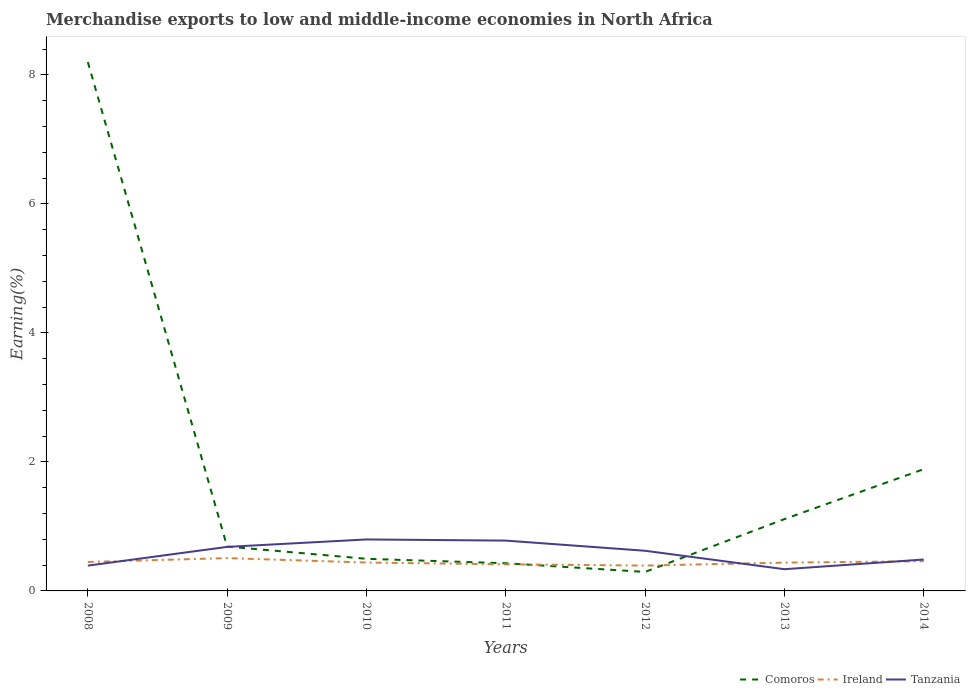How many different coloured lines are there?
Your response must be concise. 3. Is the number of lines equal to the number of legend labels?
Provide a short and direct response. Yes. Across all years, what is the maximum percentage of amount earned from merchandise exports in Tanzania?
Make the answer very short. 0.34. In which year was the percentage of amount earned from merchandise exports in Tanzania maximum?
Make the answer very short. 2013. What is the total percentage of amount earned from merchandise exports in Comoros in the graph?
Make the answer very short. -0.62. What is the difference between the highest and the second highest percentage of amount earned from merchandise exports in Ireland?
Offer a terse response. 0.12. Is the percentage of amount earned from merchandise exports in Ireland strictly greater than the percentage of amount earned from merchandise exports in Comoros over the years?
Your answer should be very brief. No. Does the graph contain any zero values?
Provide a short and direct response. No. Where does the legend appear in the graph?
Your response must be concise. Bottom right. How are the legend labels stacked?
Offer a very short reply. Horizontal. What is the title of the graph?
Ensure brevity in your answer.  Merchandise exports to low and middle-income economies in North Africa. What is the label or title of the X-axis?
Provide a short and direct response. Years. What is the label or title of the Y-axis?
Offer a very short reply. Earning(%). What is the Earning(%) of Comoros in 2008?
Provide a succinct answer. 8.2. What is the Earning(%) of Ireland in 2008?
Give a very brief answer. 0.45. What is the Earning(%) in Tanzania in 2008?
Offer a very short reply. 0.39. What is the Earning(%) of Comoros in 2009?
Provide a short and direct response. 0.69. What is the Earning(%) in Ireland in 2009?
Keep it short and to the point. 0.51. What is the Earning(%) in Tanzania in 2009?
Keep it short and to the point. 0.68. What is the Earning(%) in Comoros in 2010?
Provide a succinct answer. 0.5. What is the Earning(%) of Ireland in 2010?
Offer a terse response. 0.44. What is the Earning(%) in Tanzania in 2010?
Your answer should be very brief. 0.8. What is the Earning(%) of Comoros in 2011?
Your answer should be compact. 0.43. What is the Earning(%) in Ireland in 2011?
Your answer should be very brief. 0.41. What is the Earning(%) in Tanzania in 2011?
Keep it short and to the point. 0.78. What is the Earning(%) in Comoros in 2012?
Provide a short and direct response. 0.29. What is the Earning(%) of Ireland in 2012?
Provide a succinct answer. 0.39. What is the Earning(%) in Tanzania in 2012?
Provide a succinct answer. 0.62. What is the Earning(%) of Comoros in 2013?
Your answer should be compact. 1.11. What is the Earning(%) in Ireland in 2013?
Give a very brief answer. 0.44. What is the Earning(%) in Tanzania in 2013?
Make the answer very short. 0.34. What is the Earning(%) of Comoros in 2014?
Your answer should be compact. 1.89. What is the Earning(%) of Ireland in 2014?
Offer a very short reply. 0.46. What is the Earning(%) of Tanzania in 2014?
Make the answer very short. 0.49. Across all years, what is the maximum Earning(%) in Comoros?
Ensure brevity in your answer.  8.2. Across all years, what is the maximum Earning(%) of Ireland?
Your answer should be compact. 0.51. Across all years, what is the maximum Earning(%) of Tanzania?
Keep it short and to the point. 0.8. Across all years, what is the minimum Earning(%) of Comoros?
Ensure brevity in your answer.  0.29. Across all years, what is the minimum Earning(%) in Ireland?
Your answer should be compact. 0.39. Across all years, what is the minimum Earning(%) of Tanzania?
Make the answer very short. 0.34. What is the total Earning(%) of Comoros in the graph?
Your response must be concise. 13.11. What is the total Earning(%) in Ireland in the graph?
Make the answer very short. 3.1. What is the total Earning(%) in Tanzania in the graph?
Make the answer very short. 4.1. What is the difference between the Earning(%) of Comoros in 2008 and that in 2009?
Provide a short and direct response. 7.51. What is the difference between the Earning(%) of Ireland in 2008 and that in 2009?
Give a very brief answer. -0.06. What is the difference between the Earning(%) of Tanzania in 2008 and that in 2009?
Offer a terse response. -0.29. What is the difference between the Earning(%) of Comoros in 2008 and that in 2010?
Your answer should be compact. 7.7. What is the difference between the Earning(%) of Ireland in 2008 and that in 2010?
Provide a short and direct response. 0.01. What is the difference between the Earning(%) in Tanzania in 2008 and that in 2010?
Offer a terse response. -0.41. What is the difference between the Earning(%) of Comoros in 2008 and that in 2011?
Your response must be concise. 7.77. What is the difference between the Earning(%) in Ireland in 2008 and that in 2011?
Provide a succinct answer. 0.04. What is the difference between the Earning(%) of Tanzania in 2008 and that in 2011?
Offer a very short reply. -0.39. What is the difference between the Earning(%) of Comoros in 2008 and that in 2012?
Keep it short and to the point. 7.9. What is the difference between the Earning(%) in Ireland in 2008 and that in 2012?
Offer a terse response. 0.06. What is the difference between the Earning(%) in Tanzania in 2008 and that in 2012?
Keep it short and to the point. -0.23. What is the difference between the Earning(%) of Comoros in 2008 and that in 2013?
Your answer should be compact. 7.09. What is the difference between the Earning(%) in Ireland in 2008 and that in 2013?
Your answer should be very brief. 0.01. What is the difference between the Earning(%) of Tanzania in 2008 and that in 2013?
Offer a very short reply. 0.06. What is the difference between the Earning(%) of Comoros in 2008 and that in 2014?
Offer a terse response. 6.31. What is the difference between the Earning(%) of Ireland in 2008 and that in 2014?
Keep it short and to the point. -0.01. What is the difference between the Earning(%) in Tanzania in 2008 and that in 2014?
Offer a terse response. -0.09. What is the difference between the Earning(%) in Comoros in 2009 and that in 2010?
Keep it short and to the point. 0.19. What is the difference between the Earning(%) of Ireland in 2009 and that in 2010?
Make the answer very short. 0.07. What is the difference between the Earning(%) in Tanzania in 2009 and that in 2010?
Your response must be concise. -0.12. What is the difference between the Earning(%) in Comoros in 2009 and that in 2011?
Give a very brief answer. 0.26. What is the difference between the Earning(%) of Ireland in 2009 and that in 2011?
Ensure brevity in your answer.  0.1. What is the difference between the Earning(%) of Tanzania in 2009 and that in 2011?
Your answer should be very brief. -0.1. What is the difference between the Earning(%) of Comoros in 2009 and that in 2012?
Keep it short and to the point. 0.39. What is the difference between the Earning(%) in Ireland in 2009 and that in 2012?
Offer a terse response. 0.12. What is the difference between the Earning(%) of Tanzania in 2009 and that in 2012?
Your answer should be very brief. 0.06. What is the difference between the Earning(%) in Comoros in 2009 and that in 2013?
Your response must be concise. -0.43. What is the difference between the Earning(%) in Ireland in 2009 and that in 2013?
Ensure brevity in your answer.  0.07. What is the difference between the Earning(%) of Tanzania in 2009 and that in 2013?
Your answer should be compact. 0.35. What is the difference between the Earning(%) in Comoros in 2009 and that in 2014?
Provide a short and direct response. -1.2. What is the difference between the Earning(%) of Ireland in 2009 and that in 2014?
Offer a very short reply. 0.05. What is the difference between the Earning(%) in Tanzania in 2009 and that in 2014?
Your answer should be compact. 0.2. What is the difference between the Earning(%) of Comoros in 2010 and that in 2011?
Keep it short and to the point. 0.07. What is the difference between the Earning(%) in Ireland in 2010 and that in 2011?
Your answer should be very brief. 0.03. What is the difference between the Earning(%) of Tanzania in 2010 and that in 2011?
Provide a succinct answer. 0.02. What is the difference between the Earning(%) in Comoros in 2010 and that in 2012?
Your response must be concise. 0.2. What is the difference between the Earning(%) in Ireland in 2010 and that in 2012?
Offer a very short reply. 0.05. What is the difference between the Earning(%) in Tanzania in 2010 and that in 2012?
Offer a very short reply. 0.18. What is the difference between the Earning(%) in Comoros in 2010 and that in 2013?
Make the answer very short. -0.62. What is the difference between the Earning(%) in Ireland in 2010 and that in 2013?
Offer a very short reply. 0. What is the difference between the Earning(%) of Tanzania in 2010 and that in 2013?
Your answer should be compact. 0.46. What is the difference between the Earning(%) of Comoros in 2010 and that in 2014?
Your answer should be compact. -1.39. What is the difference between the Earning(%) in Ireland in 2010 and that in 2014?
Provide a succinct answer. -0.02. What is the difference between the Earning(%) of Tanzania in 2010 and that in 2014?
Provide a succinct answer. 0.31. What is the difference between the Earning(%) in Comoros in 2011 and that in 2012?
Offer a terse response. 0.13. What is the difference between the Earning(%) of Ireland in 2011 and that in 2012?
Offer a very short reply. 0.02. What is the difference between the Earning(%) in Tanzania in 2011 and that in 2012?
Keep it short and to the point. 0.16. What is the difference between the Earning(%) in Comoros in 2011 and that in 2013?
Provide a short and direct response. -0.68. What is the difference between the Earning(%) of Ireland in 2011 and that in 2013?
Keep it short and to the point. -0.03. What is the difference between the Earning(%) in Tanzania in 2011 and that in 2013?
Make the answer very short. 0.44. What is the difference between the Earning(%) in Comoros in 2011 and that in 2014?
Give a very brief answer. -1.46. What is the difference between the Earning(%) in Ireland in 2011 and that in 2014?
Give a very brief answer. -0.05. What is the difference between the Earning(%) of Tanzania in 2011 and that in 2014?
Provide a short and direct response. 0.29. What is the difference between the Earning(%) of Comoros in 2012 and that in 2013?
Offer a very short reply. -0.82. What is the difference between the Earning(%) in Ireland in 2012 and that in 2013?
Make the answer very short. -0.05. What is the difference between the Earning(%) in Tanzania in 2012 and that in 2013?
Offer a very short reply. 0.29. What is the difference between the Earning(%) of Comoros in 2012 and that in 2014?
Give a very brief answer. -1.59. What is the difference between the Earning(%) of Ireland in 2012 and that in 2014?
Keep it short and to the point. -0.07. What is the difference between the Earning(%) of Tanzania in 2012 and that in 2014?
Your answer should be very brief. 0.14. What is the difference between the Earning(%) of Comoros in 2013 and that in 2014?
Keep it short and to the point. -0.77. What is the difference between the Earning(%) of Ireland in 2013 and that in 2014?
Give a very brief answer. -0.02. What is the difference between the Earning(%) of Tanzania in 2013 and that in 2014?
Keep it short and to the point. -0.15. What is the difference between the Earning(%) in Comoros in 2008 and the Earning(%) in Ireland in 2009?
Provide a short and direct response. 7.69. What is the difference between the Earning(%) of Comoros in 2008 and the Earning(%) of Tanzania in 2009?
Your response must be concise. 7.52. What is the difference between the Earning(%) in Ireland in 2008 and the Earning(%) in Tanzania in 2009?
Give a very brief answer. -0.23. What is the difference between the Earning(%) of Comoros in 2008 and the Earning(%) of Ireland in 2010?
Your answer should be compact. 7.76. What is the difference between the Earning(%) of Comoros in 2008 and the Earning(%) of Tanzania in 2010?
Give a very brief answer. 7.4. What is the difference between the Earning(%) of Ireland in 2008 and the Earning(%) of Tanzania in 2010?
Make the answer very short. -0.35. What is the difference between the Earning(%) of Comoros in 2008 and the Earning(%) of Ireland in 2011?
Offer a terse response. 7.79. What is the difference between the Earning(%) in Comoros in 2008 and the Earning(%) in Tanzania in 2011?
Your answer should be very brief. 7.42. What is the difference between the Earning(%) in Ireland in 2008 and the Earning(%) in Tanzania in 2011?
Your answer should be compact. -0.33. What is the difference between the Earning(%) of Comoros in 2008 and the Earning(%) of Ireland in 2012?
Keep it short and to the point. 7.81. What is the difference between the Earning(%) in Comoros in 2008 and the Earning(%) in Tanzania in 2012?
Keep it short and to the point. 7.58. What is the difference between the Earning(%) in Ireland in 2008 and the Earning(%) in Tanzania in 2012?
Make the answer very short. -0.17. What is the difference between the Earning(%) of Comoros in 2008 and the Earning(%) of Ireland in 2013?
Provide a short and direct response. 7.76. What is the difference between the Earning(%) of Comoros in 2008 and the Earning(%) of Tanzania in 2013?
Your answer should be very brief. 7.86. What is the difference between the Earning(%) of Ireland in 2008 and the Earning(%) of Tanzania in 2013?
Your response must be concise. 0.11. What is the difference between the Earning(%) of Comoros in 2008 and the Earning(%) of Ireland in 2014?
Your response must be concise. 7.74. What is the difference between the Earning(%) in Comoros in 2008 and the Earning(%) in Tanzania in 2014?
Give a very brief answer. 7.71. What is the difference between the Earning(%) in Ireland in 2008 and the Earning(%) in Tanzania in 2014?
Keep it short and to the point. -0.04. What is the difference between the Earning(%) of Comoros in 2009 and the Earning(%) of Ireland in 2010?
Give a very brief answer. 0.25. What is the difference between the Earning(%) in Comoros in 2009 and the Earning(%) in Tanzania in 2010?
Provide a short and direct response. -0.11. What is the difference between the Earning(%) in Ireland in 2009 and the Earning(%) in Tanzania in 2010?
Provide a short and direct response. -0.29. What is the difference between the Earning(%) in Comoros in 2009 and the Earning(%) in Ireland in 2011?
Provide a short and direct response. 0.28. What is the difference between the Earning(%) in Comoros in 2009 and the Earning(%) in Tanzania in 2011?
Give a very brief answer. -0.09. What is the difference between the Earning(%) of Ireland in 2009 and the Earning(%) of Tanzania in 2011?
Your response must be concise. -0.27. What is the difference between the Earning(%) in Comoros in 2009 and the Earning(%) in Ireland in 2012?
Your response must be concise. 0.29. What is the difference between the Earning(%) of Comoros in 2009 and the Earning(%) of Tanzania in 2012?
Provide a short and direct response. 0.07. What is the difference between the Earning(%) in Ireland in 2009 and the Earning(%) in Tanzania in 2012?
Offer a terse response. -0.11. What is the difference between the Earning(%) in Comoros in 2009 and the Earning(%) in Ireland in 2013?
Your response must be concise. 0.25. What is the difference between the Earning(%) in Comoros in 2009 and the Earning(%) in Tanzania in 2013?
Offer a terse response. 0.35. What is the difference between the Earning(%) in Ireland in 2009 and the Earning(%) in Tanzania in 2013?
Your response must be concise. 0.17. What is the difference between the Earning(%) in Comoros in 2009 and the Earning(%) in Ireland in 2014?
Keep it short and to the point. 0.23. What is the difference between the Earning(%) in Comoros in 2009 and the Earning(%) in Tanzania in 2014?
Ensure brevity in your answer.  0.2. What is the difference between the Earning(%) in Ireland in 2009 and the Earning(%) in Tanzania in 2014?
Provide a succinct answer. 0.02. What is the difference between the Earning(%) in Comoros in 2010 and the Earning(%) in Ireland in 2011?
Provide a succinct answer. 0.09. What is the difference between the Earning(%) in Comoros in 2010 and the Earning(%) in Tanzania in 2011?
Ensure brevity in your answer.  -0.28. What is the difference between the Earning(%) in Ireland in 2010 and the Earning(%) in Tanzania in 2011?
Your answer should be compact. -0.34. What is the difference between the Earning(%) of Comoros in 2010 and the Earning(%) of Ireland in 2012?
Your answer should be compact. 0.1. What is the difference between the Earning(%) of Comoros in 2010 and the Earning(%) of Tanzania in 2012?
Your response must be concise. -0.12. What is the difference between the Earning(%) of Ireland in 2010 and the Earning(%) of Tanzania in 2012?
Offer a very short reply. -0.18. What is the difference between the Earning(%) in Comoros in 2010 and the Earning(%) in Ireland in 2013?
Your answer should be very brief. 0.06. What is the difference between the Earning(%) of Comoros in 2010 and the Earning(%) of Tanzania in 2013?
Give a very brief answer. 0.16. What is the difference between the Earning(%) of Ireland in 2010 and the Earning(%) of Tanzania in 2013?
Keep it short and to the point. 0.1. What is the difference between the Earning(%) of Comoros in 2010 and the Earning(%) of Ireland in 2014?
Your answer should be very brief. 0.04. What is the difference between the Earning(%) in Comoros in 2010 and the Earning(%) in Tanzania in 2014?
Keep it short and to the point. 0.01. What is the difference between the Earning(%) in Ireland in 2010 and the Earning(%) in Tanzania in 2014?
Offer a very short reply. -0.05. What is the difference between the Earning(%) in Comoros in 2011 and the Earning(%) in Ireland in 2012?
Your answer should be compact. 0.04. What is the difference between the Earning(%) in Comoros in 2011 and the Earning(%) in Tanzania in 2012?
Offer a terse response. -0.19. What is the difference between the Earning(%) in Ireland in 2011 and the Earning(%) in Tanzania in 2012?
Offer a very short reply. -0.21. What is the difference between the Earning(%) in Comoros in 2011 and the Earning(%) in Ireland in 2013?
Make the answer very short. -0.01. What is the difference between the Earning(%) of Comoros in 2011 and the Earning(%) of Tanzania in 2013?
Offer a terse response. 0.09. What is the difference between the Earning(%) of Ireland in 2011 and the Earning(%) of Tanzania in 2013?
Your answer should be compact. 0.08. What is the difference between the Earning(%) in Comoros in 2011 and the Earning(%) in Ireland in 2014?
Provide a succinct answer. -0.03. What is the difference between the Earning(%) in Comoros in 2011 and the Earning(%) in Tanzania in 2014?
Your answer should be very brief. -0.06. What is the difference between the Earning(%) in Ireland in 2011 and the Earning(%) in Tanzania in 2014?
Your answer should be very brief. -0.07. What is the difference between the Earning(%) of Comoros in 2012 and the Earning(%) of Ireland in 2013?
Provide a short and direct response. -0.14. What is the difference between the Earning(%) of Comoros in 2012 and the Earning(%) of Tanzania in 2013?
Your answer should be very brief. -0.04. What is the difference between the Earning(%) of Ireland in 2012 and the Earning(%) of Tanzania in 2013?
Keep it short and to the point. 0.06. What is the difference between the Earning(%) in Comoros in 2012 and the Earning(%) in Ireland in 2014?
Offer a terse response. -0.17. What is the difference between the Earning(%) in Comoros in 2012 and the Earning(%) in Tanzania in 2014?
Your answer should be compact. -0.19. What is the difference between the Earning(%) in Ireland in 2012 and the Earning(%) in Tanzania in 2014?
Make the answer very short. -0.09. What is the difference between the Earning(%) in Comoros in 2013 and the Earning(%) in Ireland in 2014?
Provide a succinct answer. 0.65. What is the difference between the Earning(%) in Comoros in 2013 and the Earning(%) in Tanzania in 2014?
Provide a succinct answer. 0.63. What is the difference between the Earning(%) of Ireland in 2013 and the Earning(%) of Tanzania in 2014?
Provide a succinct answer. -0.05. What is the average Earning(%) in Comoros per year?
Keep it short and to the point. 1.87. What is the average Earning(%) in Ireland per year?
Your answer should be compact. 0.44. What is the average Earning(%) in Tanzania per year?
Your answer should be compact. 0.59. In the year 2008, what is the difference between the Earning(%) of Comoros and Earning(%) of Ireland?
Offer a very short reply. 7.75. In the year 2008, what is the difference between the Earning(%) in Comoros and Earning(%) in Tanzania?
Your answer should be very brief. 7.81. In the year 2008, what is the difference between the Earning(%) in Ireland and Earning(%) in Tanzania?
Your answer should be very brief. 0.06. In the year 2009, what is the difference between the Earning(%) in Comoros and Earning(%) in Ireland?
Make the answer very short. 0.18. In the year 2009, what is the difference between the Earning(%) in Comoros and Earning(%) in Tanzania?
Keep it short and to the point. 0.01. In the year 2009, what is the difference between the Earning(%) in Ireland and Earning(%) in Tanzania?
Provide a short and direct response. -0.17. In the year 2010, what is the difference between the Earning(%) of Comoros and Earning(%) of Ireland?
Provide a succinct answer. 0.06. In the year 2010, what is the difference between the Earning(%) in Comoros and Earning(%) in Tanzania?
Your answer should be compact. -0.3. In the year 2010, what is the difference between the Earning(%) of Ireland and Earning(%) of Tanzania?
Provide a succinct answer. -0.36. In the year 2011, what is the difference between the Earning(%) in Comoros and Earning(%) in Ireland?
Provide a succinct answer. 0.02. In the year 2011, what is the difference between the Earning(%) of Comoros and Earning(%) of Tanzania?
Keep it short and to the point. -0.35. In the year 2011, what is the difference between the Earning(%) in Ireland and Earning(%) in Tanzania?
Offer a terse response. -0.37. In the year 2012, what is the difference between the Earning(%) in Comoros and Earning(%) in Ireland?
Provide a short and direct response. -0.1. In the year 2012, what is the difference between the Earning(%) in Comoros and Earning(%) in Tanzania?
Provide a short and direct response. -0.33. In the year 2012, what is the difference between the Earning(%) of Ireland and Earning(%) of Tanzania?
Give a very brief answer. -0.23. In the year 2013, what is the difference between the Earning(%) in Comoros and Earning(%) in Ireland?
Give a very brief answer. 0.67. In the year 2013, what is the difference between the Earning(%) of Comoros and Earning(%) of Tanzania?
Offer a very short reply. 0.78. In the year 2013, what is the difference between the Earning(%) in Ireland and Earning(%) in Tanzania?
Give a very brief answer. 0.1. In the year 2014, what is the difference between the Earning(%) of Comoros and Earning(%) of Ireland?
Offer a terse response. 1.43. In the year 2014, what is the difference between the Earning(%) of Comoros and Earning(%) of Tanzania?
Your answer should be compact. 1.4. In the year 2014, what is the difference between the Earning(%) in Ireland and Earning(%) in Tanzania?
Make the answer very short. -0.03. What is the ratio of the Earning(%) in Comoros in 2008 to that in 2009?
Your response must be concise. 11.92. What is the ratio of the Earning(%) of Ireland in 2008 to that in 2009?
Give a very brief answer. 0.88. What is the ratio of the Earning(%) of Tanzania in 2008 to that in 2009?
Make the answer very short. 0.57. What is the ratio of the Earning(%) in Comoros in 2008 to that in 2010?
Offer a very short reply. 16.46. What is the ratio of the Earning(%) of Ireland in 2008 to that in 2010?
Provide a succinct answer. 1.02. What is the ratio of the Earning(%) of Tanzania in 2008 to that in 2010?
Ensure brevity in your answer.  0.49. What is the ratio of the Earning(%) of Comoros in 2008 to that in 2011?
Your answer should be compact. 19.11. What is the ratio of the Earning(%) in Ireland in 2008 to that in 2011?
Your answer should be compact. 1.09. What is the ratio of the Earning(%) in Tanzania in 2008 to that in 2011?
Your answer should be compact. 0.5. What is the ratio of the Earning(%) in Comoros in 2008 to that in 2012?
Offer a very short reply. 27.83. What is the ratio of the Earning(%) of Ireland in 2008 to that in 2012?
Offer a very short reply. 1.14. What is the ratio of the Earning(%) of Tanzania in 2008 to that in 2012?
Offer a very short reply. 0.63. What is the ratio of the Earning(%) in Comoros in 2008 to that in 2013?
Give a very brief answer. 7.37. What is the ratio of the Earning(%) of Tanzania in 2008 to that in 2013?
Provide a short and direct response. 1.16. What is the ratio of the Earning(%) of Comoros in 2008 to that in 2014?
Provide a succinct answer. 4.34. What is the ratio of the Earning(%) of Ireland in 2008 to that in 2014?
Your answer should be compact. 0.97. What is the ratio of the Earning(%) of Tanzania in 2008 to that in 2014?
Make the answer very short. 0.81. What is the ratio of the Earning(%) of Comoros in 2009 to that in 2010?
Give a very brief answer. 1.38. What is the ratio of the Earning(%) of Ireland in 2009 to that in 2010?
Ensure brevity in your answer.  1.16. What is the ratio of the Earning(%) of Tanzania in 2009 to that in 2010?
Your answer should be very brief. 0.86. What is the ratio of the Earning(%) in Comoros in 2009 to that in 2011?
Provide a succinct answer. 1.6. What is the ratio of the Earning(%) of Ireland in 2009 to that in 2011?
Ensure brevity in your answer.  1.23. What is the ratio of the Earning(%) in Tanzania in 2009 to that in 2011?
Offer a very short reply. 0.88. What is the ratio of the Earning(%) in Comoros in 2009 to that in 2012?
Ensure brevity in your answer.  2.33. What is the ratio of the Earning(%) in Ireland in 2009 to that in 2012?
Make the answer very short. 1.29. What is the ratio of the Earning(%) of Tanzania in 2009 to that in 2012?
Your response must be concise. 1.1. What is the ratio of the Earning(%) in Comoros in 2009 to that in 2013?
Make the answer very short. 0.62. What is the ratio of the Earning(%) in Ireland in 2009 to that in 2013?
Offer a terse response. 1.16. What is the ratio of the Earning(%) of Tanzania in 2009 to that in 2013?
Offer a very short reply. 2.03. What is the ratio of the Earning(%) in Comoros in 2009 to that in 2014?
Ensure brevity in your answer.  0.36. What is the ratio of the Earning(%) in Ireland in 2009 to that in 2014?
Give a very brief answer. 1.1. What is the ratio of the Earning(%) of Tanzania in 2009 to that in 2014?
Provide a short and direct response. 1.4. What is the ratio of the Earning(%) of Comoros in 2010 to that in 2011?
Ensure brevity in your answer.  1.16. What is the ratio of the Earning(%) of Ireland in 2010 to that in 2011?
Ensure brevity in your answer.  1.07. What is the ratio of the Earning(%) of Tanzania in 2010 to that in 2011?
Provide a short and direct response. 1.02. What is the ratio of the Earning(%) in Comoros in 2010 to that in 2012?
Your answer should be compact. 1.69. What is the ratio of the Earning(%) in Ireland in 2010 to that in 2012?
Offer a very short reply. 1.12. What is the ratio of the Earning(%) of Tanzania in 2010 to that in 2012?
Provide a short and direct response. 1.28. What is the ratio of the Earning(%) of Comoros in 2010 to that in 2013?
Give a very brief answer. 0.45. What is the ratio of the Earning(%) in Ireland in 2010 to that in 2013?
Keep it short and to the point. 1. What is the ratio of the Earning(%) of Tanzania in 2010 to that in 2013?
Make the answer very short. 2.37. What is the ratio of the Earning(%) of Comoros in 2010 to that in 2014?
Your answer should be very brief. 0.26. What is the ratio of the Earning(%) of Ireland in 2010 to that in 2014?
Provide a succinct answer. 0.96. What is the ratio of the Earning(%) of Tanzania in 2010 to that in 2014?
Provide a short and direct response. 1.64. What is the ratio of the Earning(%) of Comoros in 2011 to that in 2012?
Keep it short and to the point. 1.46. What is the ratio of the Earning(%) in Tanzania in 2011 to that in 2012?
Make the answer very short. 1.25. What is the ratio of the Earning(%) in Comoros in 2011 to that in 2013?
Make the answer very short. 0.39. What is the ratio of the Earning(%) of Ireland in 2011 to that in 2013?
Ensure brevity in your answer.  0.94. What is the ratio of the Earning(%) of Tanzania in 2011 to that in 2013?
Offer a terse response. 2.32. What is the ratio of the Earning(%) in Comoros in 2011 to that in 2014?
Make the answer very short. 0.23. What is the ratio of the Earning(%) of Ireland in 2011 to that in 2014?
Your answer should be compact. 0.9. What is the ratio of the Earning(%) in Tanzania in 2011 to that in 2014?
Provide a succinct answer. 1.6. What is the ratio of the Earning(%) of Comoros in 2012 to that in 2013?
Offer a very short reply. 0.26. What is the ratio of the Earning(%) in Ireland in 2012 to that in 2013?
Give a very brief answer. 0.9. What is the ratio of the Earning(%) in Tanzania in 2012 to that in 2013?
Your response must be concise. 1.85. What is the ratio of the Earning(%) in Comoros in 2012 to that in 2014?
Your answer should be very brief. 0.16. What is the ratio of the Earning(%) of Ireland in 2012 to that in 2014?
Your answer should be compact. 0.85. What is the ratio of the Earning(%) of Tanzania in 2012 to that in 2014?
Offer a very short reply. 1.28. What is the ratio of the Earning(%) in Comoros in 2013 to that in 2014?
Your answer should be compact. 0.59. What is the ratio of the Earning(%) of Ireland in 2013 to that in 2014?
Keep it short and to the point. 0.95. What is the ratio of the Earning(%) of Tanzania in 2013 to that in 2014?
Give a very brief answer. 0.69. What is the difference between the highest and the second highest Earning(%) of Comoros?
Keep it short and to the point. 6.31. What is the difference between the highest and the second highest Earning(%) in Ireland?
Offer a terse response. 0.05. What is the difference between the highest and the second highest Earning(%) of Tanzania?
Make the answer very short. 0.02. What is the difference between the highest and the lowest Earning(%) of Comoros?
Make the answer very short. 7.9. What is the difference between the highest and the lowest Earning(%) in Ireland?
Ensure brevity in your answer.  0.12. What is the difference between the highest and the lowest Earning(%) in Tanzania?
Your answer should be compact. 0.46. 